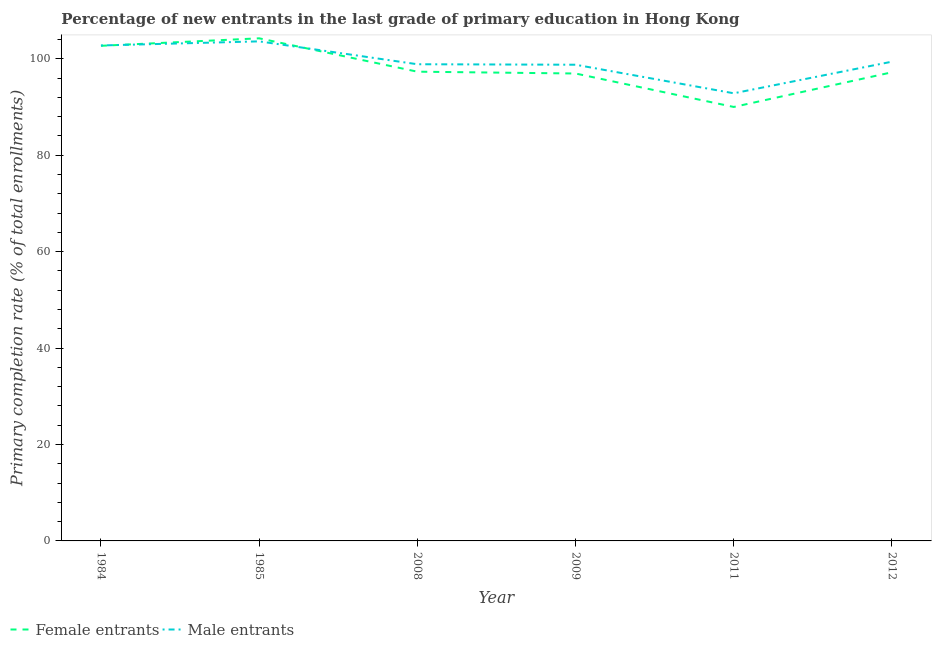How many different coloured lines are there?
Your answer should be compact. 2. Does the line corresponding to primary completion rate of female entrants intersect with the line corresponding to primary completion rate of male entrants?
Offer a very short reply. Yes. Is the number of lines equal to the number of legend labels?
Keep it short and to the point. Yes. What is the primary completion rate of female entrants in 1985?
Give a very brief answer. 104.23. Across all years, what is the maximum primary completion rate of female entrants?
Ensure brevity in your answer.  104.23. Across all years, what is the minimum primary completion rate of female entrants?
Your answer should be very brief. 90. In which year was the primary completion rate of male entrants minimum?
Offer a very short reply. 2011. What is the total primary completion rate of male entrants in the graph?
Give a very brief answer. 596.18. What is the difference between the primary completion rate of female entrants in 1985 and that in 2008?
Your response must be concise. 6.92. What is the difference between the primary completion rate of female entrants in 2008 and the primary completion rate of male entrants in 1984?
Your answer should be very brief. -5.44. What is the average primary completion rate of female entrants per year?
Your answer should be very brief. 98.06. In the year 2012, what is the difference between the primary completion rate of female entrants and primary completion rate of male entrants?
Your answer should be very brief. -2.2. What is the ratio of the primary completion rate of female entrants in 2008 to that in 2012?
Provide a short and direct response. 1. Is the primary completion rate of male entrants in 2008 less than that in 2012?
Make the answer very short. Yes. What is the difference between the highest and the second highest primary completion rate of male entrants?
Offer a very short reply. 0.85. What is the difference between the highest and the lowest primary completion rate of female entrants?
Provide a short and direct response. 14.24. Does the primary completion rate of male entrants monotonically increase over the years?
Ensure brevity in your answer.  No. Is the primary completion rate of female entrants strictly greater than the primary completion rate of male entrants over the years?
Offer a very short reply. No. How many years are there in the graph?
Make the answer very short. 6. Are the values on the major ticks of Y-axis written in scientific E-notation?
Ensure brevity in your answer.  No. How are the legend labels stacked?
Offer a very short reply. Horizontal. What is the title of the graph?
Make the answer very short. Percentage of new entrants in the last grade of primary education in Hong Kong. What is the label or title of the X-axis?
Your answer should be compact. Year. What is the label or title of the Y-axis?
Offer a very short reply. Primary completion rate (% of total enrollments). What is the Primary completion rate (% of total enrollments) of Female entrants in 1984?
Ensure brevity in your answer.  102.68. What is the Primary completion rate (% of total enrollments) of Male entrants in 1984?
Make the answer very short. 102.75. What is the Primary completion rate (% of total enrollments) of Female entrants in 1985?
Provide a short and direct response. 104.23. What is the Primary completion rate (% of total enrollments) of Male entrants in 1985?
Keep it short and to the point. 103.6. What is the Primary completion rate (% of total enrollments) of Female entrants in 2008?
Keep it short and to the point. 97.31. What is the Primary completion rate (% of total enrollments) of Male entrants in 2008?
Provide a short and direct response. 98.86. What is the Primary completion rate (% of total enrollments) in Female entrants in 2009?
Provide a succinct answer. 96.93. What is the Primary completion rate (% of total enrollments) in Male entrants in 2009?
Your answer should be very brief. 98.76. What is the Primary completion rate (% of total enrollments) in Female entrants in 2011?
Give a very brief answer. 90. What is the Primary completion rate (% of total enrollments) of Male entrants in 2011?
Provide a succinct answer. 92.83. What is the Primary completion rate (% of total enrollments) in Female entrants in 2012?
Keep it short and to the point. 97.19. What is the Primary completion rate (% of total enrollments) in Male entrants in 2012?
Your answer should be very brief. 99.39. Across all years, what is the maximum Primary completion rate (% of total enrollments) in Female entrants?
Ensure brevity in your answer.  104.23. Across all years, what is the maximum Primary completion rate (% of total enrollments) of Male entrants?
Your answer should be compact. 103.6. Across all years, what is the minimum Primary completion rate (% of total enrollments) in Female entrants?
Give a very brief answer. 90. Across all years, what is the minimum Primary completion rate (% of total enrollments) in Male entrants?
Your answer should be compact. 92.83. What is the total Primary completion rate (% of total enrollments) of Female entrants in the graph?
Ensure brevity in your answer.  588.35. What is the total Primary completion rate (% of total enrollments) of Male entrants in the graph?
Make the answer very short. 596.18. What is the difference between the Primary completion rate (% of total enrollments) of Female entrants in 1984 and that in 1985?
Make the answer very short. -1.55. What is the difference between the Primary completion rate (% of total enrollments) in Male entrants in 1984 and that in 1985?
Your answer should be very brief. -0.85. What is the difference between the Primary completion rate (% of total enrollments) of Female entrants in 1984 and that in 2008?
Provide a short and direct response. 5.37. What is the difference between the Primary completion rate (% of total enrollments) in Male entrants in 1984 and that in 2008?
Provide a short and direct response. 3.89. What is the difference between the Primary completion rate (% of total enrollments) of Female entrants in 1984 and that in 2009?
Your answer should be very brief. 5.75. What is the difference between the Primary completion rate (% of total enrollments) of Male entrants in 1984 and that in 2009?
Offer a terse response. 3.99. What is the difference between the Primary completion rate (% of total enrollments) of Female entrants in 1984 and that in 2011?
Your response must be concise. 12.68. What is the difference between the Primary completion rate (% of total enrollments) of Male entrants in 1984 and that in 2011?
Your answer should be compact. 9.92. What is the difference between the Primary completion rate (% of total enrollments) of Female entrants in 1984 and that in 2012?
Offer a very short reply. 5.49. What is the difference between the Primary completion rate (% of total enrollments) of Male entrants in 1984 and that in 2012?
Give a very brief answer. 3.36. What is the difference between the Primary completion rate (% of total enrollments) in Female entrants in 1985 and that in 2008?
Give a very brief answer. 6.92. What is the difference between the Primary completion rate (% of total enrollments) of Male entrants in 1985 and that in 2008?
Provide a short and direct response. 4.74. What is the difference between the Primary completion rate (% of total enrollments) in Female entrants in 1985 and that in 2009?
Keep it short and to the point. 7.3. What is the difference between the Primary completion rate (% of total enrollments) in Male entrants in 1985 and that in 2009?
Provide a short and direct response. 4.85. What is the difference between the Primary completion rate (% of total enrollments) in Female entrants in 1985 and that in 2011?
Give a very brief answer. 14.24. What is the difference between the Primary completion rate (% of total enrollments) of Male entrants in 1985 and that in 2011?
Offer a terse response. 10.77. What is the difference between the Primary completion rate (% of total enrollments) of Female entrants in 1985 and that in 2012?
Your response must be concise. 7.04. What is the difference between the Primary completion rate (% of total enrollments) of Male entrants in 1985 and that in 2012?
Your response must be concise. 4.21. What is the difference between the Primary completion rate (% of total enrollments) in Female entrants in 2008 and that in 2009?
Make the answer very short. 0.38. What is the difference between the Primary completion rate (% of total enrollments) of Male entrants in 2008 and that in 2009?
Your response must be concise. 0.1. What is the difference between the Primary completion rate (% of total enrollments) of Female entrants in 2008 and that in 2011?
Offer a terse response. 7.32. What is the difference between the Primary completion rate (% of total enrollments) of Male entrants in 2008 and that in 2011?
Provide a succinct answer. 6.02. What is the difference between the Primary completion rate (% of total enrollments) of Female entrants in 2008 and that in 2012?
Make the answer very short. 0.12. What is the difference between the Primary completion rate (% of total enrollments) of Male entrants in 2008 and that in 2012?
Give a very brief answer. -0.53. What is the difference between the Primary completion rate (% of total enrollments) of Female entrants in 2009 and that in 2011?
Provide a short and direct response. 6.94. What is the difference between the Primary completion rate (% of total enrollments) in Male entrants in 2009 and that in 2011?
Your answer should be compact. 5.92. What is the difference between the Primary completion rate (% of total enrollments) in Female entrants in 2009 and that in 2012?
Keep it short and to the point. -0.26. What is the difference between the Primary completion rate (% of total enrollments) of Male entrants in 2009 and that in 2012?
Provide a short and direct response. -0.63. What is the difference between the Primary completion rate (% of total enrollments) in Female entrants in 2011 and that in 2012?
Give a very brief answer. -7.19. What is the difference between the Primary completion rate (% of total enrollments) of Male entrants in 2011 and that in 2012?
Offer a very short reply. -6.56. What is the difference between the Primary completion rate (% of total enrollments) of Female entrants in 1984 and the Primary completion rate (% of total enrollments) of Male entrants in 1985?
Give a very brief answer. -0.92. What is the difference between the Primary completion rate (% of total enrollments) in Female entrants in 1984 and the Primary completion rate (% of total enrollments) in Male entrants in 2008?
Offer a very short reply. 3.82. What is the difference between the Primary completion rate (% of total enrollments) of Female entrants in 1984 and the Primary completion rate (% of total enrollments) of Male entrants in 2009?
Keep it short and to the point. 3.93. What is the difference between the Primary completion rate (% of total enrollments) of Female entrants in 1984 and the Primary completion rate (% of total enrollments) of Male entrants in 2011?
Your response must be concise. 9.85. What is the difference between the Primary completion rate (% of total enrollments) of Female entrants in 1984 and the Primary completion rate (% of total enrollments) of Male entrants in 2012?
Your answer should be compact. 3.29. What is the difference between the Primary completion rate (% of total enrollments) in Female entrants in 1985 and the Primary completion rate (% of total enrollments) in Male entrants in 2008?
Your answer should be compact. 5.38. What is the difference between the Primary completion rate (% of total enrollments) in Female entrants in 1985 and the Primary completion rate (% of total enrollments) in Male entrants in 2009?
Your response must be concise. 5.48. What is the difference between the Primary completion rate (% of total enrollments) in Female entrants in 1985 and the Primary completion rate (% of total enrollments) in Male entrants in 2011?
Offer a terse response. 11.4. What is the difference between the Primary completion rate (% of total enrollments) of Female entrants in 1985 and the Primary completion rate (% of total enrollments) of Male entrants in 2012?
Give a very brief answer. 4.85. What is the difference between the Primary completion rate (% of total enrollments) in Female entrants in 2008 and the Primary completion rate (% of total enrollments) in Male entrants in 2009?
Your answer should be compact. -1.44. What is the difference between the Primary completion rate (% of total enrollments) of Female entrants in 2008 and the Primary completion rate (% of total enrollments) of Male entrants in 2011?
Keep it short and to the point. 4.48. What is the difference between the Primary completion rate (% of total enrollments) in Female entrants in 2008 and the Primary completion rate (% of total enrollments) in Male entrants in 2012?
Offer a very short reply. -2.07. What is the difference between the Primary completion rate (% of total enrollments) of Female entrants in 2009 and the Primary completion rate (% of total enrollments) of Male entrants in 2011?
Offer a very short reply. 4.1. What is the difference between the Primary completion rate (% of total enrollments) in Female entrants in 2009 and the Primary completion rate (% of total enrollments) in Male entrants in 2012?
Offer a terse response. -2.45. What is the difference between the Primary completion rate (% of total enrollments) of Female entrants in 2011 and the Primary completion rate (% of total enrollments) of Male entrants in 2012?
Offer a very short reply. -9.39. What is the average Primary completion rate (% of total enrollments) of Female entrants per year?
Your answer should be very brief. 98.06. What is the average Primary completion rate (% of total enrollments) in Male entrants per year?
Provide a short and direct response. 99.36. In the year 1984, what is the difference between the Primary completion rate (% of total enrollments) of Female entrants and Primary completion rate (% of total enrollments) of Male entrants?
Your response must be concise. -0.07. In the year 1985, what is the difference between the Primary completion rate (% of total enrollments) in Female entrants and Primary completion rate (% of total enrollments) in Male entrants?
Ensure brevity in your answer.  0.63. In the year 2008, what is the difference between the Primary completion rate (% of total enrollments) in Female entrants and Primary completion rate (% of total enrollments) in Male entrants?
Make the answer very short. -1.54. In the year 2009, what is the difference between the Primary completion rate (% of total enrollments) of Female entrants and Primary completion rate (% of total enrollments) of Male entrants?
Give a very brief answer. -1.82. In the year 2011, what is the difference between the Primary completion rate (% of total enrollments) in Female entrants and Primary completion rate (% of total enrollments) in Male entrants?
Give a very brief answer. -2.83. In the year 2012, what is the difference between the Primary completion rate (% of total enrollments) in Female entrants and Primary completion rate (% of total enrollments) in Male entrants?
Provide a succinct answer. -2.2. What is the ratio of the Primary completion rate (% of total enrollments) in Female entrants in 1984 to that in 1985?
Offer a terse response. 0.99. What is the ratio of the Primary completion rate (% of total enrollments) in Female entrants in 1984 to that in 2008?
Ensure brevity in your answer.  1.06. What is the ratio of the Primary completion rate (% of total enrollments) in Male entrants in 1984 to that in 2008?
Your answer should be very brief. 1.04. What is the ratio of the Primary completion rate (% of total enrollments) of Female entrants in 1984 to that in 2009?
Your response must be concise. 1.06. What is the ratio of the Primary completion rate (% of total enrollments) of Male entrants in 1984 to that in 2009?
Your answer should be very brief. 1.04. What is the ratio of the Primary completion rate (% of total enrollments) of Female entrants in 1984 to that in 2011?
Offer a very short reply. 1.14. What is the ratio of the Primary completion rate (% of total enrollments) in Male entrants in 1984 to that in 2011?
Your answer should be very brief. 1.11. What is the ratio of the Primary completion rate (% of total enrollments) of Female entrants in 1984 to that in 2012?
Offer a very short reply. 1.06. What is the ratio of the Primary completion rate (% of total enrollments) of Male entrants in 1984 to that in 2012?
Your answer should be compact. 1.03. What is the ratio of the Primary completion rate (% of total enrollments) in Female entrants in 1985 to that in 2008?
Keep it short and to the point. 1.07. What is the ratio of the Primary completion rate (% of total enrollments) of Male entrants in 1985 to that in 2008?
Your response must be concise. 1.05. What is the ratio of the Primary completion rate (% of total enrollments) of Female entrants in 1985 to that in 2009?
Your answer should be compact. 1.08. What is the ratio of the Primary completion rate (% of total enrollments) of Male entrants in 1985 to that in 2009?
Your answer should be compact. 1.05. What is the ratio of the Primary completion rate (% of total enrollments) in Female entrants in 1985 to that in 2011?
Make the answer very short. 1.16. What is the ratio of the Primary completion rate (% of total enrollments) in Male entrants in 1985 to that in 2011?
Offer a terse response. 1.12. What is the ratio of the Primary completion rate (% of total enrollments) of Female entrants in 1985 to that in 2012?
Your response must be concise. 1.07. What is the ratio of the Primary completion rate (% of total enrollments) of Male entrants in 1985 to that in 2012?
Your answer should be very brief. 1.04. What is the ratio of the Primary completion rate (% of total enrollments) in Female entrants in 2008 to that in 2009?
Make the answer very short. 1. What is the ratio of the Primary completion rate (% of total enrollments) of Female entrants in 2008 to that in 2011?
Offer a terse response. 1.08. What is the ratio of the Primary completion rate (% of total enrollments) of Male entrants in 2008 to that in 2011?
Keep it short and to the point. 1.06. What is the ratio of the Primary completion rate (% of total enrollments) in Male entrants in 2008 to that in 2012?
Keep it short and to the point. 0.99. What is the ratio of the Primary completion rate (% of total enrollments) of Female entrants in 2009 to that in 2011?
Offer a terse response. 1.08. What is the ratio of the Primary completion rate (% of total enrollments) of Male entrants in 2009 to that in 2011?
Keep it short and to the point. 1.06. What is the ratio of the Primary completion rate (% of total enrollments) of Female entrants in 2011 to that in 2012?
Provide a succinct answer. 0.93. What is the ratio of the Primary completion rate (% of total enrollments) of Male entrants in 2011 to that in 2012?
Your answer should be compact. 0.93. What is the difference between the highest and the second highest Primary completion rate (% of total enrollments) of Female entrants?
Provide a short and direct response. 1.55. What is the difference between the highest and the second highest Primary completion rate (% of total enrollments) of Male entrants?
Provide a succinct answer. 0.85. What is the difference between the highest and the lowest Primary completion rate (% of total enrollments) in Female entrants?
Offer a very short reply. 14.24. What is the difference between the highest and the lowest Primary completion rate (% of total enrollments) in Male entrants?
Ensure brevity in your answer.  10.77. 